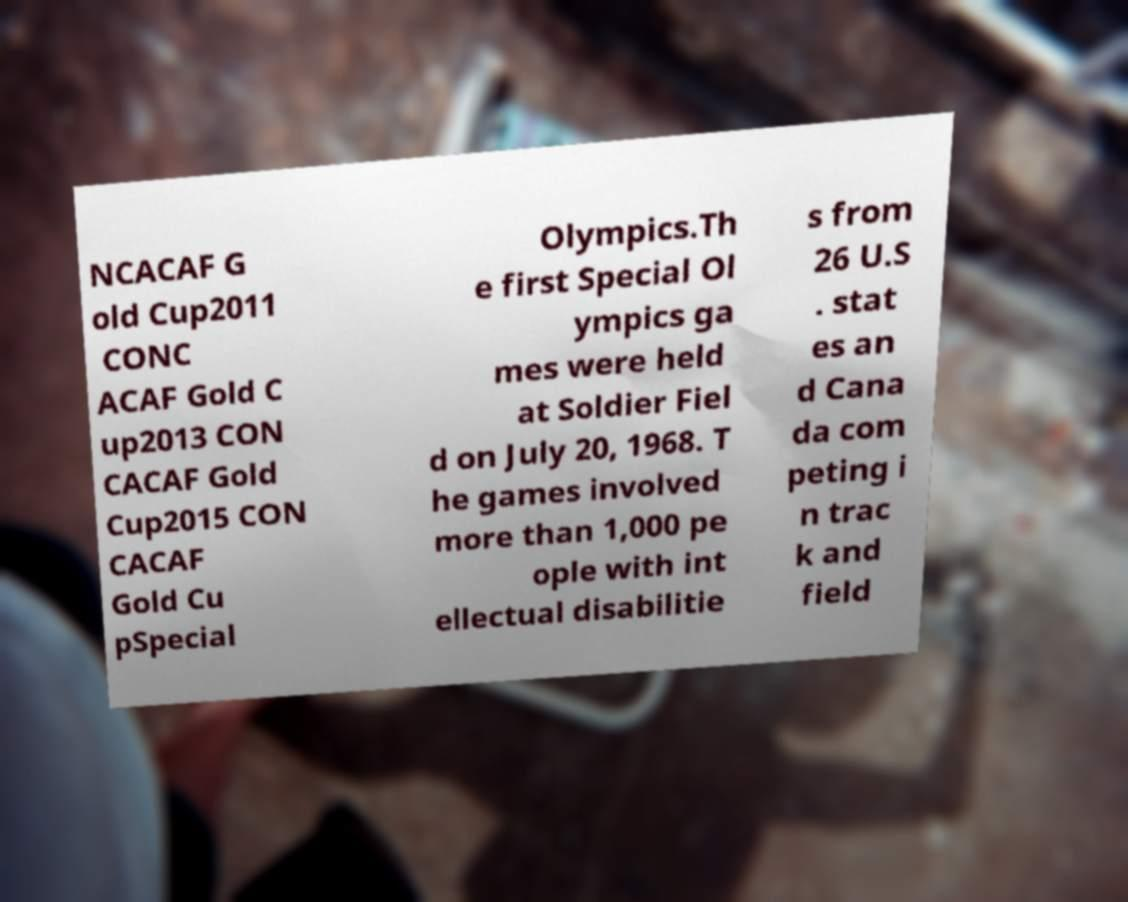Could you extract and type out the text from this image? NCACAF G old Cup2011 CONC ACAF Gold C up2013 CON CACAF Gold Cup2015 CON CACAF Gold Cu pSpecial Olympics.Th e first Special Ol ympics ga mes were held at Soldier Fiel d on July 20, 1968. T he games involved more than 1,000 pe ople with int ellectual disabilitie s from 26 U.S . stat es an d Cana da com peting i n trac k and field 